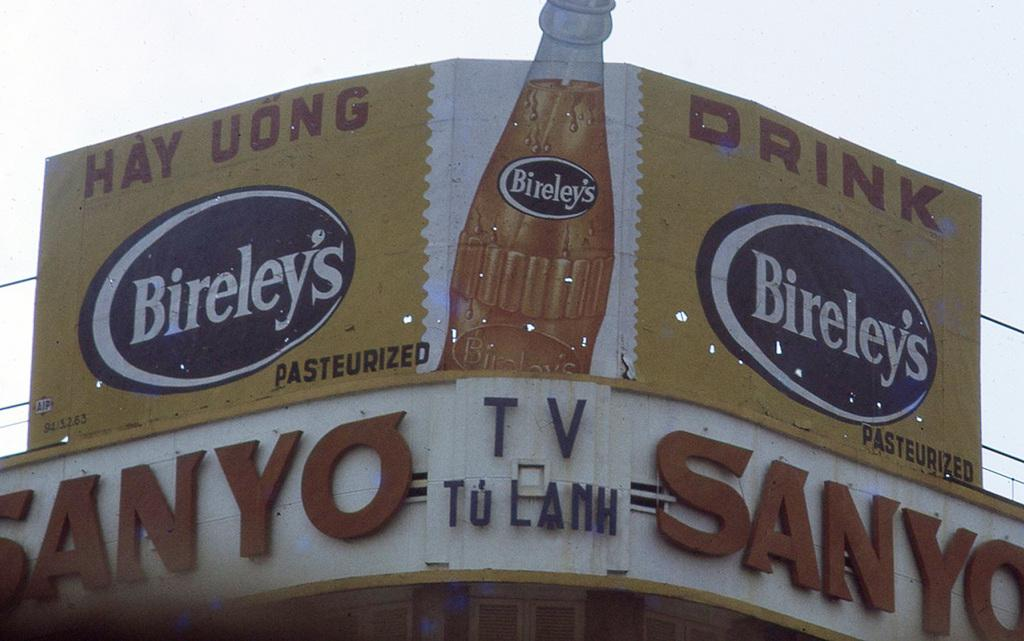<image>
Share a concise interpretation of the image provided. a billboard with a Sanyo sign located under it 